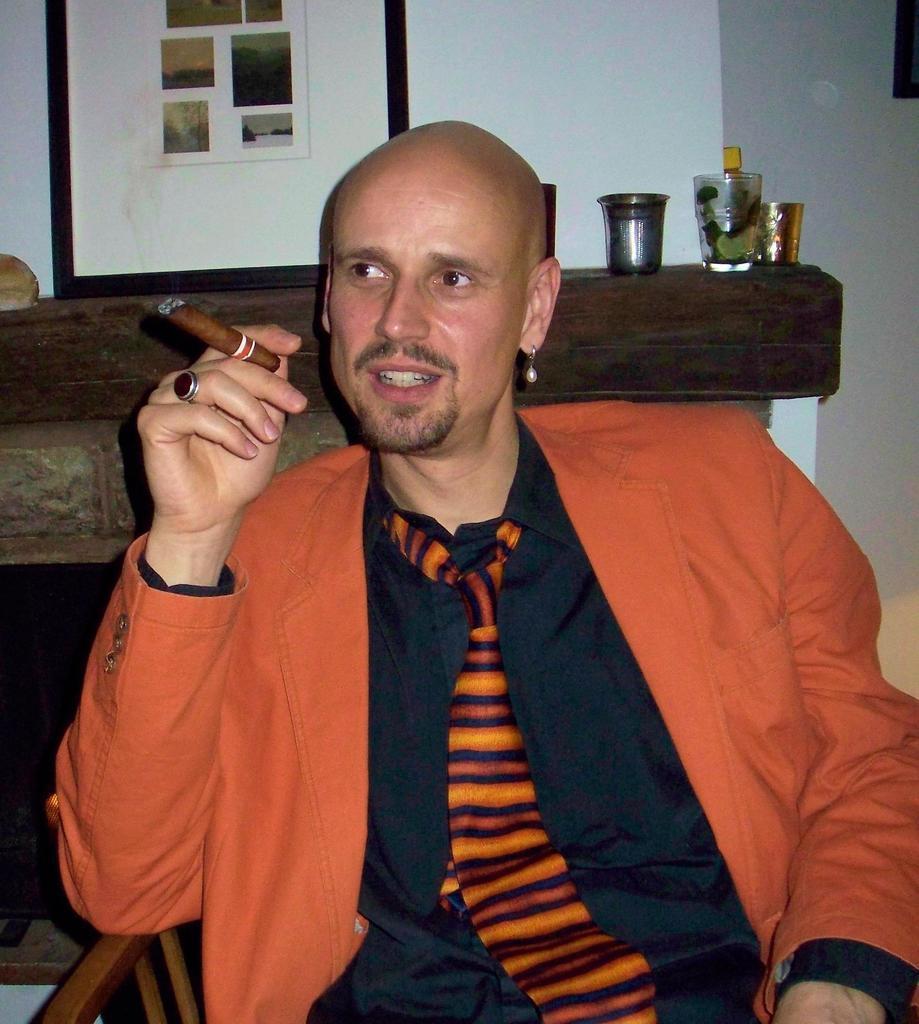Describe this image in one or two sentences. In this picture I can see there is a man sitting on the chair, he is wearing a blazer, a tie, and looking at left, he is holding a cigar and there is a wooden table with a photo frame placed on it. There is a wall in the backdrop. 